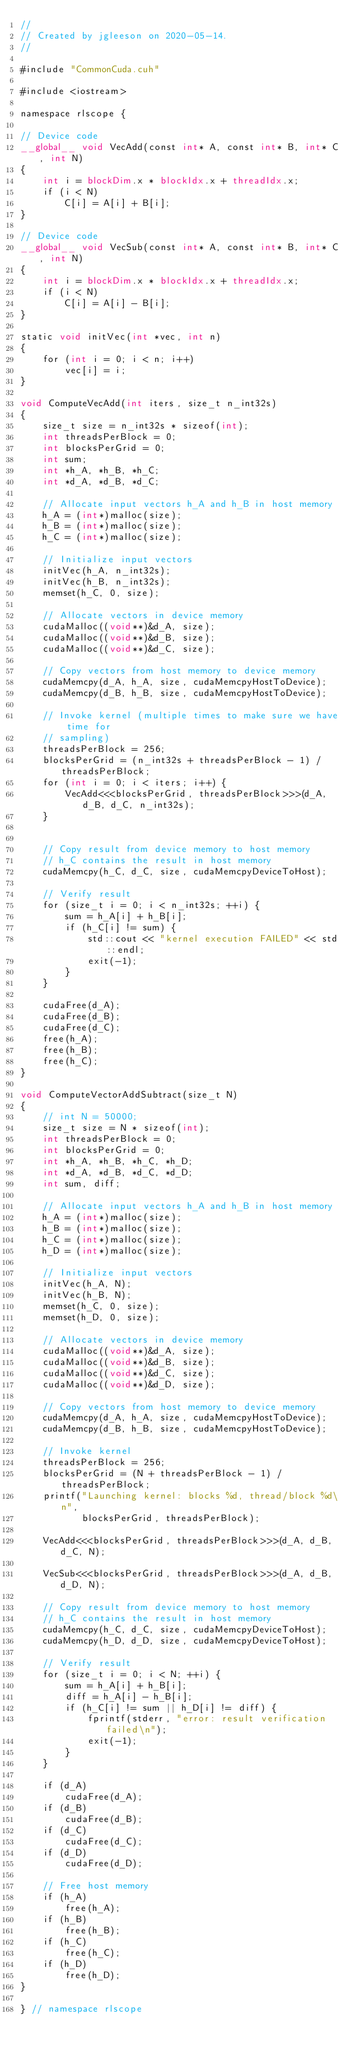Convert code to text. <code><loc_0><loc_0><loc_500><loc_500><_Cuda_>//
// Created by jgleeson on 2020-05-14.
//

#include "CommonCuda.cuh"

#include <iostream>

namespace rlscope {

// Device code
__global__ void VecAdd(const int* A, const int* B, int* C, int N)
{
    int i = blockDim.x * blockIdx.x + threadIdx.x;
    if (i < N)
        C[i] = A[i] + B[i];
}

// Device code
__global__ void VecSub(const int* A, const int* B, int* C, int N)
{
    int i = blockDim.x * blockIdx.x + threadIdx.x;
    if (i < N)
        C[i] = A[i] - B[i];
}

static void initVec(int *vec, int n)
{
    for (int i = 0; i < n; i++)
        vec[i] = i;
}

void ComputeVecAdd(int iters, size_t n_int32s)
{
    size_t size = n_int32s * sizeof(int);
    int threadsPerBlock = 0;
    int blocksPerGrid = 0;
    int sum;
    int *h_A, *h_B, *h_C;
    int *d_A, *d_B, *d_C;

    // Allocate input vectors h_A and h_B in host memory
    h_A = (int*)malloc(size);
    h_B = (int*)malloc(size);
    h_C = (int*)malloc(size);

    // Initialize input vectors
    initVec(h_A, n_int32s);
    initVec(h_B, n_int32s);
    memset(h_C, 0, size);

    // Allocate vectors in device memory
    cudaMalloc((void**)&d_A, size);
    cudaMalloc((void**)&d_B, size);
    cudaMalloc((void**)&d_C, size);

    // Copy vectors from host memory to device memory
    cudaMemcpy(d_A, h_A, size, cudaMemcpyHostToDevice);
    cudaMemcpy(d_B, h_B, size, cudaMemcpyHostToDevice);

    // Invoke kernel (multiple times to make sure we have time for
    // sampling)
    threadsPerBlock = 256;
    blocksPerGrid = (n_int32s + threadsPerBlock - 1) / threadsPerBlock;
    for (int i = 0; i < iters; i++) {
        VecAdd<<<blocksPerGrid, threadsPerBlock>>>(d_A, d_B, d_C, n_int32s);
    }


    // Copy result from device memory to host memory
    // h_C contains the result in host memory
    cudaMemcpy(h_C, d_C, size, cudaMemcpyDeviceToHost);

    // Verify result
    for (size_t i = 0; i < n_int32s; ++i) {
        sum = h_A[i] + h_B[i];
        if (h_C[i] != sum) {
            std::cout << "kernel execution FAILED" << std::endl;
            exit(-1);
        }
    }

    cudaFree(d_A);
    cudaFree(d_B);
    cudaFree(d_C);
    free(h_A);
    free(h_B);
    free(h_C);
}

void ComputeVectorAddSubtract(size_t N)
{
    // int N = 50000;
    size_t size = N * sizeof(int);
    int threadsPerBlock = 0;
    int blocksPerGrid = 0;
    int *h_A, *h_B, *h_C, *h_D;
    int *d_A, *d_B, *d_C, *d_D;
    int sum, diff;

    // Allocate input vectors h_A and h_B in host memory
    h_A = (int*)malloc(size);
    h_B = (int*)malloc(size);
    h_C = (int*)malloc(size);
    h_D = (int*)malloc(size);

    // Initialize input vectors
    initVec(h_A, N);
    initVec(h_B, N);
    memset(h_C, 0, size);
    memset(h_D, 0, size);

    // Allocate vectors in device memory
    cudaMalloc((void**)&d_A, size);
    cudaMalloc((void**)&d_B, size);
    cudaMalloc((void**)&d_C, size);
    cudaMalloc((void**)&d_D, size);

    // Copy vectors from host memory to device memory
    cudaMemcpy(d_A, h_A, size, cudaMemcpyHostToDevice);
    cudaMemcpy(d_B, h_B, size, cudaMemcpyHostToDevice);

    // Invoke kernel
    threadsPerBlock = 256;
    blocksPerGrid = (N + threadsPerBlock - 1) / threadsPerBlock;
    printf("Launching kernel: blocks %d, thread/block %d\n",
           blocksPerGrid, threadsPerBlock);

    VecAdd<<<blocksPerGrid, threadsPerBlock>>>(d_A, d_B, d_C, N);

    VecSub<<<blocksPerGrid, threadsPerBlock>>>(d_A, d_B, d_D, N);

    // Copy result from device memory to host memory
    // h_C contains the result in host memory
    cudaMemcpy(h_C, d_C, size, cudaMemcpyDeviceToHost);
    cudaMemcpy(h_D, d_D, size, cudaMemcpyDeviceToHost);

    // Verify result
    for (size_t i = 0; i < N; ++i) {
        sum = h_A[i] + h_B[i];
        diff = h_A[i] - h_B[i];
        if (h_C[i] != sum || h_D[i] != diff) {
            fprintf(stderr, "error: result verification failed\n");
            exit(-1);
        }
    }

    if (d_A)
        cudaFree(d_A);
    if (d_B)
        cudaFree(d_B);
    if (d_C)
        cudaFree(d_C);
    if (d_D)
        cudaFree(d_D);

    // Free host memory
    if (h_A)
        free(h_A);
    if (h_B)
        free(h_B);
    if (h_C)
        free(h_C);
    if (h_D)
        free(h_D);
}

} // namespace rlscope
</code> 